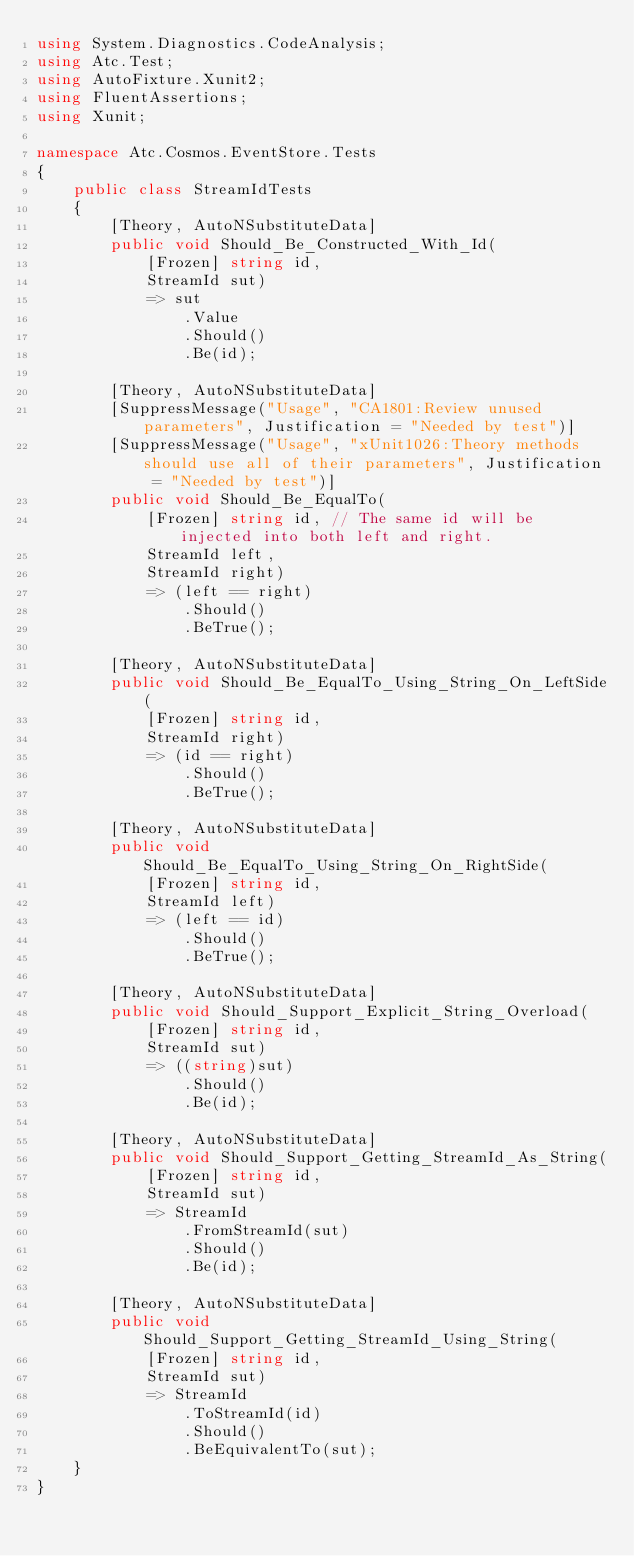<code> <loc_0><loc_0><loc_500><loc_500><_C#_>using System.Diagnostics.CodeAnalysis;
using Atc.Test;
using AutoFixture.Xunit2;
using FluentAssertions;
using Xunit;

namespace Atc.Cosmos.EventStore.Tests
{
    public class StreamIdTests
    {
        [Theory, AutoNSubstituteData]
        public void Should_Be_Constructed_With_Id(
            [Frozen] string id,
            StreamId sut)
            => sut
                .Value
                .Should()
                .Be(id);

        [Theory, AutoNSubstituteData]
        [SuppressMessage("Usage", "CA1801:Review unused parameters", Justification = "Needed by test")]
        [SuppressMessage("Usage", "xUnit1026:Theory methods should use all of their parameters", Justification = "Needed by test")]
        public void Should_Be_EqualTo(
            [Frozen] string id, // The same id will be injected into both left and right.
            StreamId left,
            StreamId right)
            => (left == right)
                .Should()
                .BeTrue();

        [Theory, AutoNSubstituteData]
        public void Should_Be_EqualTo_Using_String_On_LeftSide(
            [Frozen] string id,
            StreamId right)
            => (id == right)
                .Should()
                .BeTrue();

        [Theory, AutoNSubstituteData]
        public void Should_Be_EqualTo_Using_String_On_RightSide(
            [Frozen] string id,
            StreamId left)
            => (left == id)
                .Should()
                .BeTrue();

        [Theory, AutoNSubstituteData]
        public void Should_Support_Explicit_String_Overload(
            [Frozen] string id,
            StreamId sut)
            => ((string)sut)
                .Should()
                .Be(id);

        [Theory, AutoNSubstituteData]
        public void Should_Support_Getting_StreamId_As_String(
            [Frozen] string id,
            StreamId sut)
            => StreamId
                .FromStreamId(sut)
                .Should()
                .Be(id);

        [Theory, AutoNSubstituteData]
        public void Should_Support_Getting_StreamId_Using_String(
            [Frozen] string id,
            StreamId sut)
            => StreamId
                .ToStreamId(id)
                .Should()
                .BeEquivalentTo(sut);
    }
}</code> 